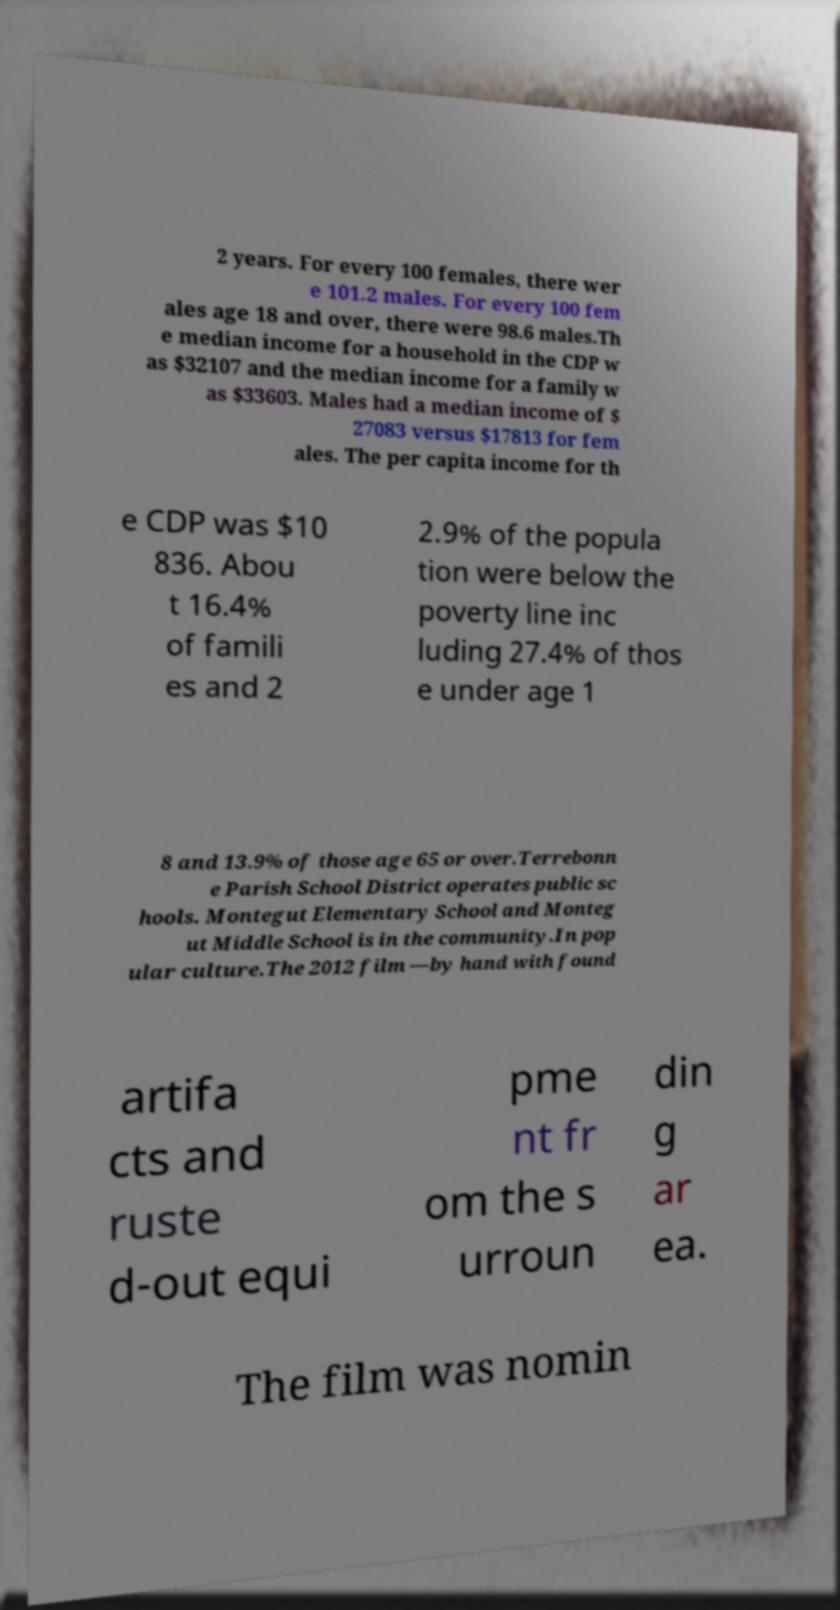Could you extract and type out the text from this image? 2 years. For every 100 females, there wer e 101.2 males. For every 100 fem ales age 18 and over, there were 98.6 males.Th e median income for a household in the CDP w as $32107 and the median income for a family w as $33603. Males had a median income of $ 27083 versus $17813 for fem ales. The per capita income for th e CDP was $10 836. Abou t 16.4% of famili es and 2 2.9% of the popula tion were below the poverty line inc luding 27.4% of thos e under age 1 8 and 13.9% of those age 65 or over.Terrebonn e Parish School District operates public sc hools. Montegut Elementary School and Monteg ut Middle School is in the community.In pop ular culture.The 2012 film —by hand with found artifa cts and ruste d-out equi pme nt fr om the s urroun din g ar ea. The film was nomin 